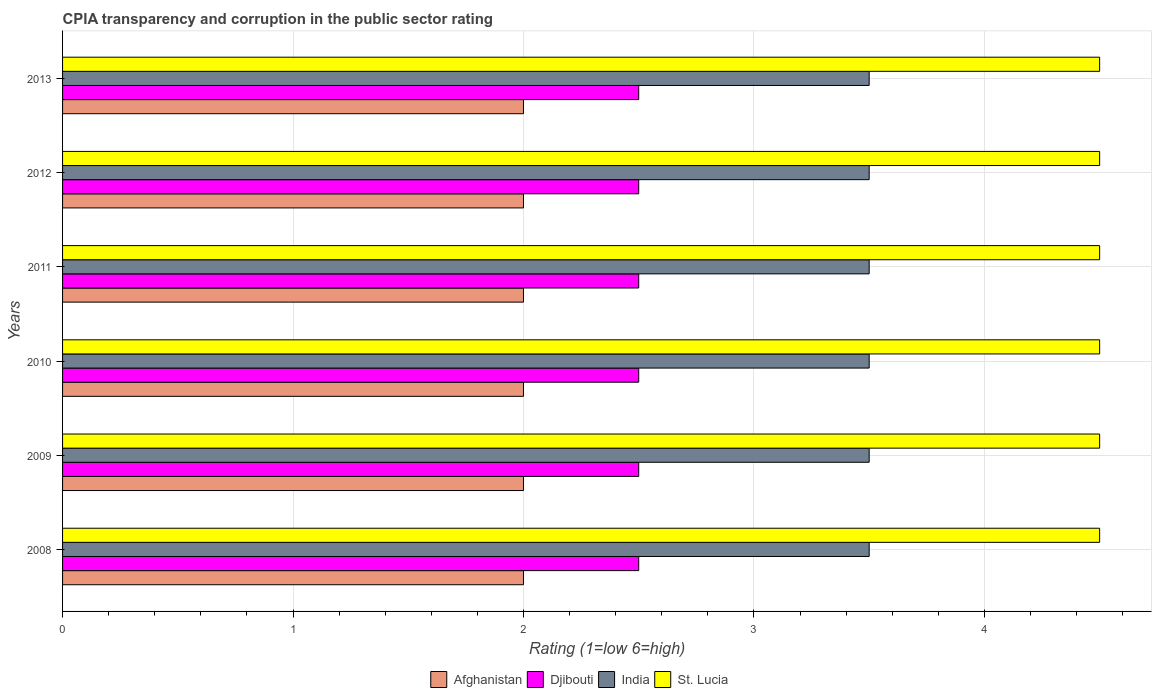How many different coloured bars are there?
Your response must be concise. 4. How many groups of bars are there?
Provide a short and direct response. 6. Are the number of bars on each tick of the Y-axis equal?
Offer a very short reply. Yes. How many bars are there on the 6th tick from the top?
Your answer should be very brief. 4. How many bars are there on the 5th tick from the bottom?
Provide a short and direct response. 4. What is the label of the 6th group of bars from the top?
Ensure brevity in your answer.  2008. Across all years, what is the maximum CPIA rating in Afghanistan?
Your answer should be compact. 2. Across all years, what is the minimum CPIA rating in Djibouti?
Your answer should be very brief. 2.5. In which year was the CPIA rating in Afghanistan maximum?
Your answer should be very brief. 2008. In how many years, is the CPIA rating in Djibouti greater than 1.2 ?
Your answer should be very brief. 6. Is the CPIA rating in Afghanistan in 2008 less than that in 2011?
Keep it short and to the point. No. Is the difference between the CPIA rating in Afghanistan in 2012 and 2013 greater than the difference between the CPIA rating in India in 2012 and 2013?
Your answer should be compact. No. What is the difference between the highest and the lowest CPIA rating in India?
Offer a terse response. 0. In how many years, is the CPIA rating in India greater than the average CPIA rating in India taken over all years?
Your answer should be compact. 0. What does the 3rd bar from the top in 2010 represents?
Keep it short and to the point. Djibouti. What does the 2nd bar from the bottom in 2011 represents?
Your answer should be very brief. Djibouti. Is it the case that in every year, the sum of the CPIA rating in Afghanistan and CPIA rating in St. Lucia is greater than the CPIA rating in Djibouti?
Keep it short and to the point. Yes. Are all the bars in the graph horizontal?
Your answer should be compact. Yes. What is the difference between two consecutive major ticks on the X-axis?
Ensure brevity in your answer.  1. Are the values on the major ticks of X-axis written in scientific E-notation?
Ensure brevity in your answer.  No. Does the graph contain any zero values?
Your answer should be very brief. No. Does the graph contain grids?
Ensure brevity in your answer.  Yes. Where does the legend appear in the graph?
Make the answer very short. Bottom center. How many legend labels are there?
Offer a terse response. 4. What is the title of the graph?
Ensure brevity in your answer.  CPIA transparency and corruption in the public sector rating. What is the label or title of the X-axis?
Make the answer very short. Rating (1=low 6=high). What is the label or title of the Y-axis?
Your answer should be very brief. Years. What is the Rating (1=low 6=high) of Afghanistan in 2008?
Offer a terse response. 2. What is the Rating (1=low 6=high) in Djibouti in 2008?
Provide a short and direct response. 2.5. What is the Rating (1=low 6=high) of India in 2008?
Keep it short and to the point. 3.5. What is the Rating (1=low 6=high) of St. Lucia in 2008?
Your answer should be compact. 4.5. What is the Rating (1=low 6=high) in Afghanistan in 2009?
Your answer should be compact. 2. What is the Rating (1=low 6=high) of Afghanistan in 2010?
Your response must be concise. 2. What is the Rating (1=low 6=high) in India in 2010?
Make the answer very short. 3.5. What is the Rating (1=low 6=high) of St. Lucia in 2010?
Your answer should be very brief. 4.5. What is the Rating (1=low 6=high) of St. Lucia in 2011?
Offer a very short reply. 4.5. What is the Rating (1=low 6=high) in India in 2012?
Offer a terse response. 3.5. Across all years, what is the maximum Rating (1=low 6=high) in Afghanistan?
Provide a succinct answer. 2. Across all years, what is the maximum Rating (1=low 6=high) in Djibouti?
Your answer should be very brief. 2.5. Across all years, what is the maximum Rating (1=low 6=high) in India?
Make the answer very short. 3.5. Across all years, what is the minimum Rating (1=low 6=high) in India?
Your answer should be very brief. 3.5. What is the total Rating (1=low 6=high) of Afghanistan in the graph?
Your answer should be compact. 12. What is the difference between the Rating (1=low 6=high) of Afghanistan in 2008 and that in 2009?
Ensure brevity in your answer.  0. What is the difference between the Rating (1=low 6=high) in Djibouti in 2008 and that in 2009?
Your answer should be very brief. 0. What is the difference between the Rating (1=low 6=high) in India in 2008 and that in 2009?
Give a very brief answer. 0. What is the difference between the Rating (1=low 6=high) in St. Lucia in 2008 and that in 2009?
Your response must be concise. 0. What is the difference between the Rating (1=low 6=high) in Djibouti in 2008 and that in 2010?
Offer a very short reply. 0. What is the difference between the Rating (1=low 6=high) of India in 2008 and that in 2010?
Ensure brevity in your answer.  0. What is the difference between the Rating (1=low 6=high) of St. Lucia in 2008 and that in 2010?
Your answer should be compact. 0. What is the difference between the Rating (1=low 6=high) of India in 2008 and that in 2011?
Offer a terse response. 0. What is the difference between the Rating (1=low 6=high) in Djibouti in 2008 and that in 2012?
Your answer should be compact. 0. What is the difference between the Rating (1=low 6=high) in India in 2008 and that in 2012?
Your answer should be compact. 0. What is the difference between the Rating (1=low 6=high) in Afghanistan in 2008 and that in 2013?
Offer a terse response. 0. What is the difference between the Rating (1=low 6=high) of Djibouti in 2008 and that in 2013?
Make the answer very short. 0. What is the difference between the Rating (1=low 6=high) of India in 2008 and that in 2013?
Provide a succinct answer. 0. What is the difference between the Rating (1=low 6=high) of Afghanistan in 2009 and that in 2010?
Your answer should be compact. 0. What is the difference between the Rating (1=low 6=high) in Djibouti in 2009 and that in 2010?
Offer a very short reply. 0. What is the difference between the Rating (1=low 6=high) in India in 2009 and that in 2010?
Keep it short and to the point. 0. What is the difference between the Rating (1=low 6=high) of St. Lucia in 2009 and that in 2010?
Your response must be concise. 0. What is the difference between the Rating (1=low 6=high) of Afghanistan in 2009 and that in 2011?
Make the answer very short. 0. What is the difference between the Rating (1=low 6=high) of India in 2009 and that in 2012?
Provide a short and direct response. 0. What is the difference between the Rating (1=low 6=high) in India in 2009 and that in 2013?
Provide a short and direct response. 0. What is the difference between the Rating (1=low 6=high) in Djibouti in 2010 and that in 2011?
Keep it short and to the point. 0. What is the difference between the Rating (1=low 6=high) in Djibouti in 2010 and that in 2012?
Provide a short and direct response. 0. What is the difference between the Rating (1=low 6=high) of St. Lucia in 2010 and that in 2012?
Offer a terse response. 0. What is the difference between the Rating (1=low 6=high) in Djibouti in 2010 and that in 2013?
Your answer should be compact. 0. What is the difference between the Rating (1=low 6=high) of St. Lucia in 2010 and that in 2013?
Ensure brevity in your answer.  0. What is the difference between the Rating (1=low 6=high) of Afghanistan in 2011 and that in 2012?
Offer a very short reply. 0. What is the difference between the Rating (1=low 6=high) in Djibouti in 2011 and that in 2012?
Offer a very short reply. 0. What is the difference between the Rating (1=low 6=high) of India in 2011 and that in 2012?
Offer a very short reply. 0. What is the difference between the Rating (1=low 6=high) of St. Lucia in 2011 and that in 2012?
Your answer should be compact. 0. What is the difference between the Rating (1=low 6=high) of Afghanistan in 2011 and that in 2013?
Provide a succinct answer. 0. What is the difference between the Rating (1=low 6=high) of St. Lucia in 2011 and that in 2013?
Keep it short and to the point. 0. What is the difference between the Rating (1=low 6=high) in Afghanistan in 2012 and that in 2013?
Your answer should be very brief. 0. What is the difference between the Rating (1=low 6=high) of St. Lucia in 2012 and that in 2013?
Keep it short and to the point. 0. What is the difference between the Rating (1=low 6=high) in Djibouti in 2008 and the Rating (1=low 6=high) in India in 2009?
Provide a short and direct response. -1. What is the difference between the Rating (1=low 6=high) in Djibouti in 2008 and the Rating (1=low 6=high) in St. Lucia in 2009?
Your response must be concise. -2. What is the difference between the Rating (1=low 6=high) of India in 2008 and the Rating (1=low 6=high) of St. Lucia in 2009?
Make the answer very short. -1. What is the difference between the Rating (1=low 6=high) in Afghanistan in 2008 and the Rating (1=low 6=high) in St. Lucia in 2010?
Ensure brevity in your answer.  -2.5. What is the difference between the Rating (1=low 6=high) of Djibouti in 2008 and the Rating (1=low 6=high) of St. Lucia in 2010?
Ensure brevity in your answer.  -2. What is the difference between the Rating (1=low 6=high) in India in 2008 and the Rating (1=low 6=high) in St. Lucia in 2010?
Provide a short and direct response. -1. What is the difference between the Rating (1=low 6=high) in Afghanistan in 2008 and the Rating (1=low 6=high) in Djibouti in 2011?
Offer a terse response. -0.5. What is the difference between the Rating (1=low 6=high) in Afghanistan in 2008 and the Rating (1=low 6=high) in India in 2011?
Provide a short and direct response. -1.5. What is the difference between the Rating (1=low 6=high) in Djibouti in 2008 and the Rating (1=low 6=high) in India in 2011?
Make the answer very short. -1. What is the difference between the Rating (1=low 6=high) in Djibouti in 2008 and the Rating (1=low 6=high) in St. Lucia in 2011?
Provide a succinct answer. -2. What is the difference between the Rating (1=low 6=high) in India in 2008 and the Rating (1=low 6=high) in St. Lucia in 2011?
Your answer should be very brief. -1. What is the difference between the Rating (1=low 6=high) in Afghanistan in 2008 and the Rating (1=low 6=high) in India in 2012?
Your response must be concise. -1.5. What is the difference between the Rating (1=low 6=high) in Djibouti in 2008 and the Rating (1=low 6=high) in India in 2012?
Offer a very short reply. -1. What is the difference between the Rating (1=low 6=high) of Djibouti in 2008 and the Rating (1=low 6=high) of St. Lucia in 2012?
Ensure brevity in your answer.  -2. What is the difference between the Rating (1=low 6=high) of Afghanistan in 2008 and the Rating (1=low 6=high) of India in 2013?
Provide a succinct answer. -1.5. What is the difference between the Rating (1=low 6=high) in India in 2008 and the Rating (1=low 6=high) in St. Lucia in 2013?
Your answer should be very brief. -1. What is the difference between the Rating (1=low 6=high) of Afghanistan in 2009 and the Rating (1=low 6=high) of Djibouti in 2010?
Provide a succinct answer. -0.5. What is the difference between the Rating (1=low 6=high) of Afghanistan in 2009 and the Rating (1=low 6=high) of St. Lucia in 2010?
Make the answer very short. -2.5. What is the difference between the Rating (1=low 6=high) in Djibouti in 2009 and the Rating (1=low 6=high) in India in 2010?
Give a very brief answer. -1. What is the difference between the Rating (1=low 6=high) of India in 2009 and the Rating (1=low 6=high) of St. Lucia in 2010?
Your answer should be compact. -1. What is the difference between the Rating (1=low 6=high) in Afghanistan in 2009 and the Rating (1=low 6=high) in Djibouti in 2011?
Provide a short and direct response. -0.5. What is the difference between the Rating (1=low 6=high) in Afghanistan in 2009 and the Rating (1=low 6=high) in India in 2011?
Ensure brevity in your answer.  -1.5. What is the difference between the Rating (1=low 6=high) in Djibouti in 2009 and the Rating (1=low 6=high) in St. Lucia in 2011?
Give a very brief answer. -2. What is the difference between the Rating (1=low 6=high) of Afghanistan in 2009 and the Rating (1=low 6=high) of St. Lucia in 2012?
Offer a very short reply. -2.5. What is the difference between the Rating (1=low 6=high) of Afghanistan in 2009 and the Rating (1=low 6=high) of Djibouti in 2013?
Provide a succinct answer. -0.5. What is the difference between the Rating (1=low 6=high) in Afghanistan in 2009 and the Rating (1=low 6=high) in India in 2013?
Your response must be concise. -1.5. What is the difference between the Rating (1=low 6=high) of Djibouti in 2009 and the Rating (1=low 6=high) of India in 2013?
Your answer should be very brief. -1. What is the difference between the Rating (1=low 6=high) in Afghanistan in 2010 and the Rating (1=low 6=high) in Djibouti in 2011?
Your answer should be compact. -0.5. What is the difference between the Rating (1=low 6=high) in Afghanistan in 2010 and the Rating (1=low 6=high) in India in 2011?
Keep it short and to the point. -1.5. What is the difference between the Rating (1=low 6=high) of Djibouti in 2010 and the Rating (1=low 6=high) of St. Lucia in 2011?
Ensure brevity in your answer.  -2. What is the difference between the Rating (1=low 6=high) in Afghanistan in 2010 and the Rating (1=low 6=high) in India in 2012?
Your answer should be compact. -1.5. What is the difference between the Rating (1=low 6=high) in Afghanistan in 2010 and the Rating (1=low 6=high) in St. Lucia in 2012?
Offer a terse response. -2.5. What is the difference between the Rating (1=low 6=high) in Djibouti in 2010 and the Rating (1=low 6=high) in St. Lucia in 2012?
Your response must be concise. -2. What is the difference between the Rating (1=low 6=high) in India in 2010 and the Rating (1=low 6=high) in St. Lucia in 2012?
Your answer should be compact. -1. What is the difference between the Rating (1=low 6=high) of Afghanistan in 2010 and the Rating (1=low 6=high) of Djibouti in 2013?
Keep it short and to the point. -0.5. What is the difference between the Rating (1=low 6=high) of Afghanistan in 2010 and the Rating (1=low 6=high) of India in 2013?
Provide a succinct answer. -1.5. What is the difference between the Rating (1=low 6=high) in Djibouti in 2010 and the Rating (1=low 6=high) in India in 2013?
Make the answer very short. -1. What is the difference between the Rating (1=low 6=high) of Djibouti in 2010 and the Rating (1=low 6=high) of St. Lucia in 2013?
Provide a succinct answer. -2. What is the difference between the Rating (1=low 6=high) in India in 2010 and the Rating (1=low 6=high) in St. Lucia in 2013?
Your response must be concise. -1. What is the difference between the Rating (1=low 6=high) in Djibouti in 2011 and the Rating (1=low 6=high) in St. Lucia in 2012?
Provide a short and direct response. -2. What is the difference between the Rating (1=low 6=high) of Afghanistan in 2011 and the Rating (1=low 6=high) of India in 2013?
Your response must be concise. -1.5. What is the difference between the Rating (1=low 6=high) of Afghanistan in 2011 and the Rating (1=low 6=high) of St. Lucia in 2013?
Your response must be concise. -2.5. What is the difference between the Rating (1=low 6=high) in Djibouti in 2011 and the Rating (1=low 6=high) in St. Lucia in 2013?
Your answer should be very brief. -2. What is the difference between the Rating (1=low 6=high) in India in 2011 and the Rating (1=low 6=high) in St. Lucia in 2013?
Offer a terse response. -1. What is the difference between the Rating (1=low 6=high) of Afghanistan in 2012 and the Rating (1=low 6=high) of Djibouti in 2013?
Offer a very short reply. -0.5. What is the difference between the Rating (1=low 6=high) in Afghanistan in 2012 and the Rating (1=low 6=high) in India in 2013?
Give a very brief answer. -1.5. What is the difference between the Rating (1=low 6=high) in Afghanistan in 2012 and the Rating (1=low 6=high) in St. Lucia in 2013?
Provide a short and direct response. -2.5. What is the difference between the Rating (1=low 6=high) of Djibouti in 2012 and the Rating (1=low 6=high) of St. Lucia in 2013?
Give a very brief answer. -2. What is the average Rating (1=low 6=high) of India per year?
Provide a short and direct response. 3.5. What is the average Rating (1=low 6=high) of St. Lucia per year?
Your answer should be very brief. 4.5. In the year 2008, what is the difference between the Rating (1=low 6=high) of Afghanistan and Rating (1=low 6=high) of India?
Offer a very short reply. -1.5. In the year 2008, what is the difference between the Rating (1=low 6=high) in Afghanistan and Rating (1=low 6=high) in St. Lucia?
Provide a short and direct response. -2.5. In the year 2008, what is the difference between the Rating (1=low 6=high) of Djibouti and Rating (1=low 6=high) of India?
Provide a succinct answer. -1. In the year 2008, what is the difference between the Rating (1=low 6=high) in India and Rating (1=low 6=high) in St. Lucia?
Offer a terse response. -1. In the year 2009, what is the difference between the Rating (1=low 6=high) of Djibouti and Rating (1=low 6=high) of India?
Provide a succinct answer. -1. In the year 2009, what is the difference between the Rating (1=low 6=high) in Djibouti and Rating (1=low 6=high) in St. Lucia?
Your response must be concise. -2. In the year 2010, what is the difference between the Rating (1=low 6=high) of Afghanistan and Rating (1=low 6=high) of St. Lucia?
Keep it short and to the point. -2.5. In the year 2010, what is the difference between the Rating (1=low 6=high) of Djibouti and Rating (1=low 6=high) of India?
Ensure brevity in your answer.  -1. In the year 2010, what is the difference between the Rating (1=low 6=high) in Djibouti and Rating (1=low 6=high) in St. Lucia?
Keep it short and to the point. -2. In the year 2010, what is the difference between the Rating (1=low 6=high) in India and Rating (1=low 6=high) in St. Lucia?
Your response must be concise. -1. In the year 2011, what is the difference between the Rating (1=low 6=high) in Afghanistan and Rating (1=low 6=high) in India?
Make the answer very short. -1.5. In the year 2011, what is the difference between the Rating (1=low 6=high) in Djibouti and Rating (1=low 6=high) in India?
Your answer should be very brief. -1. In the year 2011, what is the difference between the Rating (1=low 6=high) of India and Rating (1=low 6=high) of St. Lucia?
Offer a terse response. -1. In the year 2012, what is the difference between the Rating (1=low 6=high) of Afghanistan and Rating (1=low 6=high) of St. Lucia?
Your answer should be very brief. -2.5. In the year 2012, what is the difference between the Rating (1=low 6=high) in Djibouti and Rating (1=low 6=high) in St. Lucia?
Provide a succinct answer. -2. In the year 2013, what is the difference between the Rating (1=low 6=high) in Afghanistan and Rating (1=low 6=high) in India?
Your answer should be compact. -1.5. In the year 2013, what is the difference between the Rating (1=low 6=high) of Afghanistan and Rating (1=low 6=high) of St. Lucia?
Ensure brevity in your answer.  -2.5. In the year 2013, what is the difference between the Rating (1=low 6=high) in Djibouti and Rating (1=low 6=high) in India?
Keep it short and to the point. -1. What is the ratio of the Rating (1=low 6=high) of St. Lucia in 2008 to that in 2009?
Provide a short and direct response. 1. What is the ratio of the Rating (1=low 6=high) of India in 2008 to that in 2010?
Your answer should be very brief. 1. What is the ratio of the Rating (1=low 6=high) in St. Lucia in 2008 to that in 2010?
Offer a terse response. 1. What is the ratio of the Rating (1=low 6=high) in Afghanistan in 2008 to that in 2011?
Give a very brief answer. 1. What is the ratio of the Rating (1=low 6=high) of Djibouti in 2008 to that in 2011?
Provide a succinct answer. 1. What is the ratio of the Rating (1=low 6=high) of India in 2008 to that in 2012?
Offer a terse response. 1. What is the ratio of the Rating (1=low 6=high) in Afghanistan in 2008 to that in 2013?
Your answer should be very brief. 1. What is the ratio of the Rating (1=low 6=high) of India in 2008 to that in 2013?
Provide a short and direct response. 1. What is the ratio of the Rating (1=low 6=high) in Djibouti in 2009 to that in 2010?
Offer a very short reply. 1. What is the ratio of the Rating (1=low 6=high) of India in 2009 to that in 2010?
Provide a succinct answer. 1. What is the ratio of the Rating (1=low 6=high) in Djibouti in 2009 to that in 2011?
Keep it short and to the point. 1. What is the ratio of the Rating (1=low 6=high) of India in 2009 to that in 2011?
Offer a very short reply. 1. What is the ratio of the Rating (1=low 6=high) of Djibouti in 2009 to that in 2012?
Ensure brevity in your answer.  1. What is the ratio of the Rating (1=low 6=high) in India in 2009 to that in 2012?
Provide a succinct answer. 1. What is the ratio of the Rating (1=low 6=high) of Afghanistan in 2009 to that in 2013?
Offer a very short reply. 1. What is the ratio of the Rating (1=low 6=high) in Djibouti in 2009 to that in 2013?
Your answer should be very brief. 1. What is the ratio of the Rating (1=low 6=high) in St. Lucia in 2009 to that in 2013?
Your answer should be compact. 1. What is the ratio of the Rating (1=low 6=high) of India in 2010 to that in 2011?
Make the answer very short. 1. What is the ratio of the Rating (1=low 6=high) in St. Lucia in 2010 to that in 2011?
Your answer should be compact. 1. What is the ratio of the Rating (1=low 6=high) of Afghanistan in 2010 to that in 2012?
Provide a short and direct response. 1. What is the ratio of the Rating (1=low 6=high) of Djibouti in 2010 to that in 2012?
Provide a succinct answer. 1. What is the ratio of the Rating (1=low 6=high) in India in 2010 to that in 2012?
Keep it short and to the point. 1. What is the ratio of the Rating (1=low 6=high) in St. Lucia in 2010 to that in 2012?
Your answer should be very brief. 1. What is the ratio of the Rating (1=low 6=high) of Afghanistan in 2010 to that in 2013?
Ensure brevity in your answer.  1. What is the ratio of the Rating (1=low 6=high) in Djibouti in 2010 to that in 2013?
Keep it short and to the point. 1. What is the ratio of the Rating (1=low 6=high) of St. Lucia in 2010 to that in 2013?
Ensure brevity in your answer.  1. What is the ratio of the Rating (1=low 6=high) of Afghanistan in 2011 to that in 2012?
Provide a short and direct response. 1. What is the ratio of the Rating (1=low 6=high) in India in 2011 to that in 2012?
Provide a short and direct response. 1. What is the ratio of the Rating (1=low 6=high) in St. Lucia in 2011 to that in 2012?
Provide a short and direct response. 1. What is the ratio of the Rating (1=low 6=high) of India in 2011 to that in 2013?
Your answer should be compact. 1. What is the ratio of the Rating (1=low 6=high) of Afghanistan in 2012 to that in 2013?
Give a very brief answer. 1. What is the ratio of the Rating (1=low 6=high) of Djibouti in 2012 to that in 2013?
Provide a short and direct response. 1. What is the difference between the highest and the second highest Rating (1=low 6=high) of Afghanistan?
Keep it short and to the point. 0. What is the difference between the highest and the second highest Rating (1=low 6=high) of Djibouti?
Keep it short and to the point. 0. What is the difference between the highest and the second highest Rating (1=low 6=high) in India?
Your answer should be very brief. 0. What is the difference between the highest and the second highest Rating (1=low 6=high) of St. Lucia?
Your answer should be very brief. 0. What is the difference between the highest and the lowest Rating (1=low 6=high) of Afghanistan?
Your response must be concise. 0. What is the difference between the highest and the lowest Rating (1=low 6=high) of India?
Your answer should be compact. 0. What is the difference between the highest and the lowest Rating (1=low 6=high) in St. Lucia?
Provide a short and direct response. 0. 